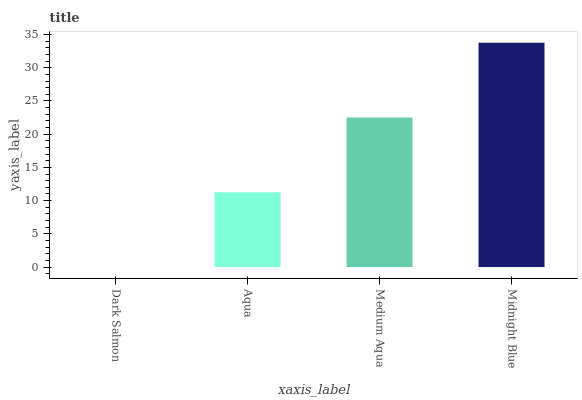Is Dark Salmon the minimum?
Answer yes or no. Yes. Is Midnight Blue the maximum?
Answer yes or no. Yes. Is Aqua the minimum?
Answer yes or no. No. Is Aqua the maximum?
Answer yes or no. No. Is Aqua greater than Dark Salmon?
Answer yes or no. Yes. Is Dark Salmon less than Aqua?
Answer yes or no. Yes. Is Dark Salmon greater than Aqua?
Answer yes or no. No. Is Aqua less than Dark Salmon?
Answer yes or no. No. Is Medium Aqua the high median?
Answer yes or no. Yes. Is Aqua the low median?
Answer yes or no. Yes. Is Midnight Blue the high median?
Answer yes or no. No. Is Dark Salmon the low median?
Answer yes or no. No. 